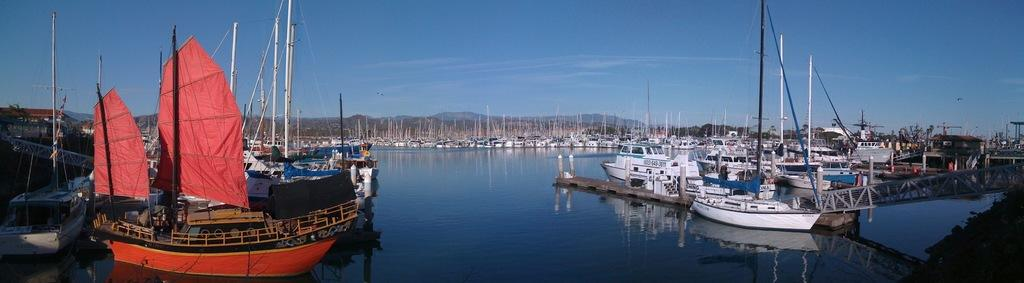What type of water body is present in the image? There is a river in the image. What is floating on the river? There are boats and ships in the river. What feature do the ships have? The ships have poles. What can be seen in the distance in the image? There are mountains visible in the background of the image. What type of instrument is being played by the blood in the image? There is no instrument or blood present in the image. 